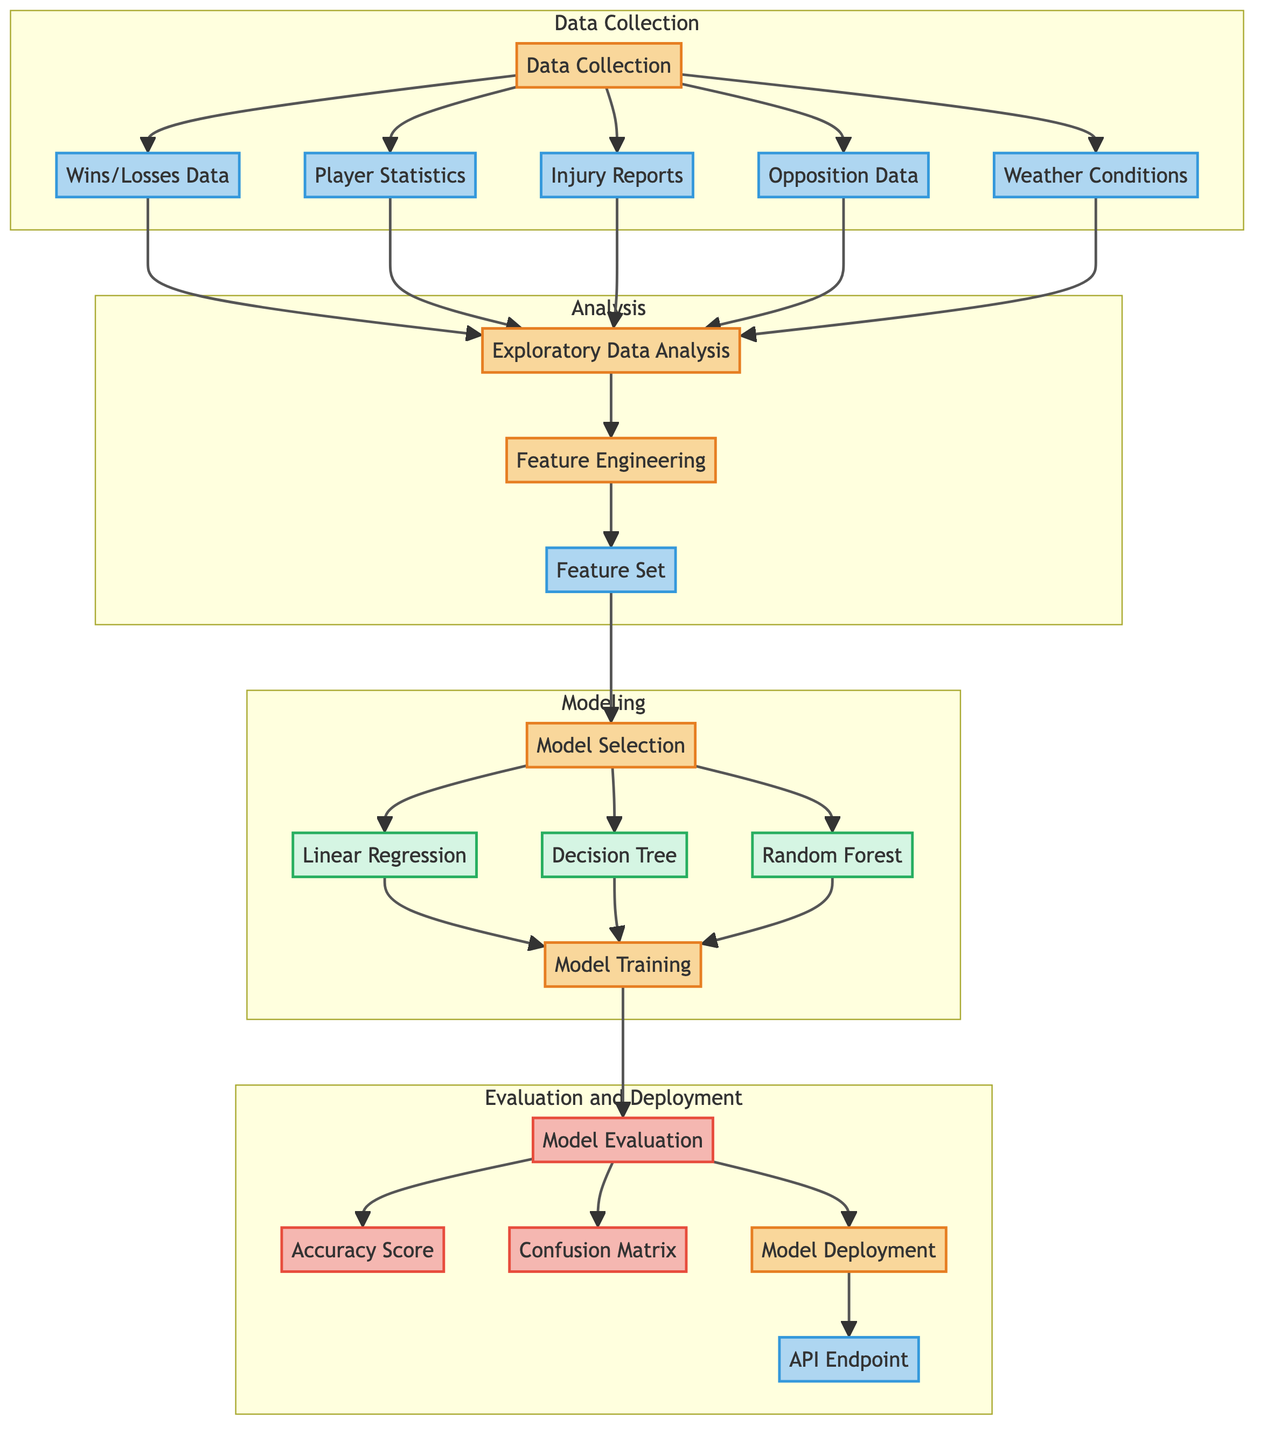What are the components of the data collection phase? The data collection phase includes Wins/Losses Data, Player Statistics, Injury Reports, Opposition Data, and Weather Conditions. These nodes are directly connected from the Data Collection node.
Answer: Wins/Losses Data, Player Statistics, Injury Reports, Opposition Data, Weather Conditions How many modeling techniques are listed in the diagram? The modeling phase includes three techniques: Linear Regression, Decision Tree, and Random Forest. This can be verified by counting the nodes within the Modeling subgraph.
Answer: Three What comes after exploratory data analysis in the diagram? After exploratory data analysis, the next process is feature engineering. This is indicated by a directional arrow flowing from the Exploratory Data Analysis node to the Feature Engineering node.
Answer: Feature Engineering How many nodes are in the evaluation and deployment section? The evaluation and deployment section consists of four nodes: Model Evaluation, Accuracy Score, Confusion Matrix, and Model Deployment. Counting these nodes gives the total number of nodes in that section.
Answer: Four Which modeling techniques are mentioned in the diagram? The diagram mentions Linear Regression, Decision Tree, and Random Forest as the modeling techniques. These can be identified by looking at the nodes within the Modeling subgraph.
Answer: Linear Regression, Decision Tree, Random Forest What is the output of the model evaluation step? The output from the model evaluation step leads to two specific evaluations: Accuracy Score and Confusion Matrix. The outputs can be traced by following the arrows from the Model Evaluation node.
Answer: Accuracy Score, Confusion Matrix What is the first step in the predictive analysis process? The first step in the predictive analysis process is Data Collection, which can be seen at the beginning of the flowchart as the initial node before any other processes.
Answer: Data Collection What is the purpose of feature engineering in the process? Feature engineering aims to create a feature set, which is indicated by the connection flowing from Feature Engineering to Feature Set. This step is crucial for preparing the data for modeling.
Answer: Create a feature set 